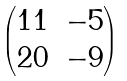Convert formula to latex. <formula><loc_0><loc_0><loc_500><loc_500>\begin{pmatrix} 1 1 & - 5 \\ 2 0 & - 9 \end{pmatrix}</formula> 